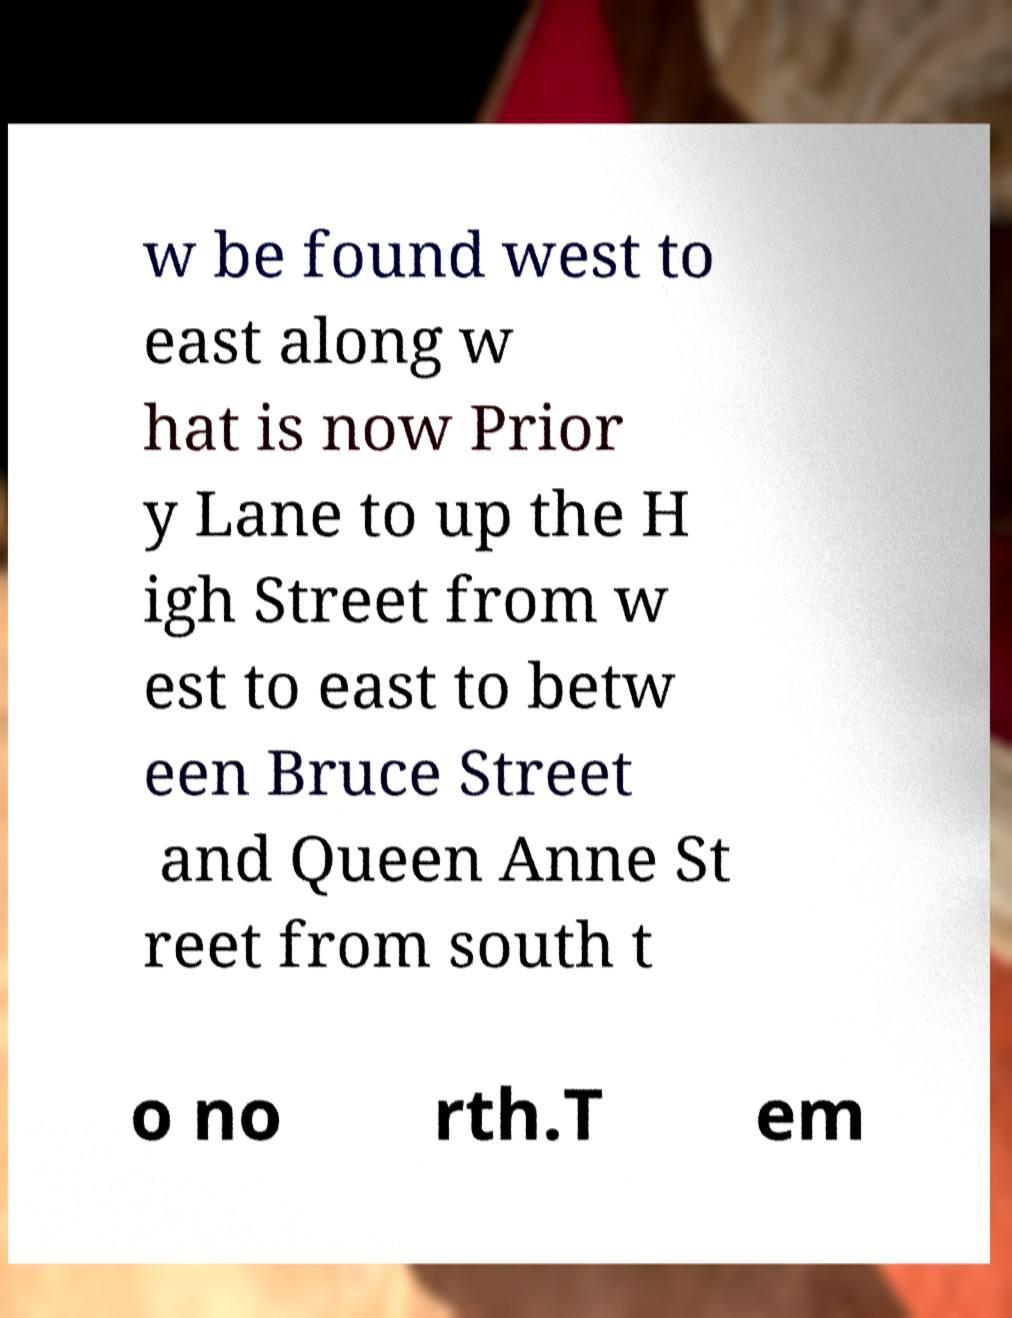Could you assist in decoding the text presented in this image and type it out clearly? w be found west to east along w hat is now Prior y Lane to up the H igh Street from w est to east to betw een Bruce Street and Queen Anne St reet from south t o no rth.T em 